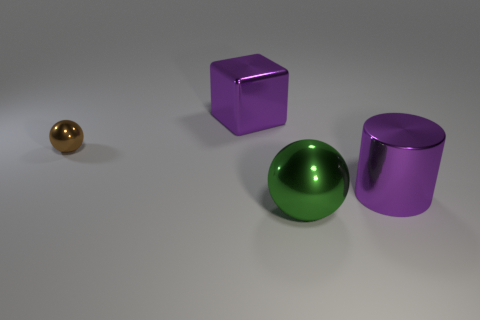Is there anything else that has the same size as the brown ball?
Your response must be concise. No. There is a brown shiny thing; does it have the same shape as the thing to the right of the big green ball?
Your response must be concise. No. Is the number of brown metal objects in front of the big metal cylinder less than the number of things right of the tiny brown object?
Your answer should be compact. Yes. There is another object that is the same shape as the tiny brown metal object; what material is it?
Your answer should be very brief. Metal. Is there anything else that has the same material as the brown ball?
Your response must be concise. Yes. Does the big metal cylinder have the same color as the large shiny sphere?
Make the answer very short. No. There is a brown thing that is the same material as the green object; what is its shape?
Make the answer very short. Sphere. How many other big metal things have the same shape as the big green object?
Keep it short and to the point. 0. There is a large purple object behind the purple metal thing that is in front of the large purple block; what shape is it?
Provide a succinct answer. Cube. There is a cylinder right of the green metal sphere; is its size the same as the green ball?
Offer a terse response. Yes. 